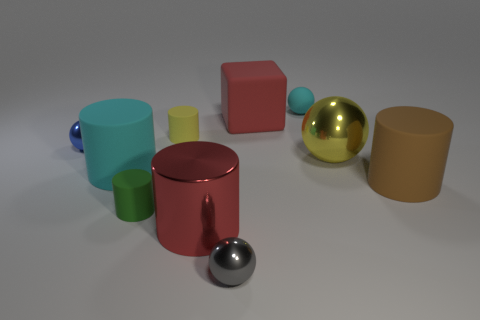There is a cyan matte thing that is left of the metal ball that is in front of the cyan object to the left of the matte cube; how big is it?
Offer a terse response. Large. There is another big rubber object that is the same shape as the large brown object; what is its color?
Offer a terse response. Cyan. Are there more big blocks that are in front of the red cube than yellow cylinders?
Keep it short and to the point. No. There is a blue metal thing; does it have the same shape as the cyan object that is left of the red shiny thing?
Offer a terse response. No. Is there anything else that is the same size as the red block?
Give a very brief answer. Yes. What size is the green rubber thing that is the same shape as the yellow rubber thing?
Provide a succinct answer. Small. Is the number of yellow matte things greater than the number of purple metal cylinders?
Offer a very short reply. Yes. Is the green object the same shape as the brown rubber object?
Offer a very short reply. Yes. There is a thing that is to the right of the metal thing on the right side of the small cyan rubber thing; what is it made of?
Ensure brevity in your answer.  Rubber. What is the material of the tiny cylinder that is the same color as the large metal ball?
Your response must be concise. Rubber. 